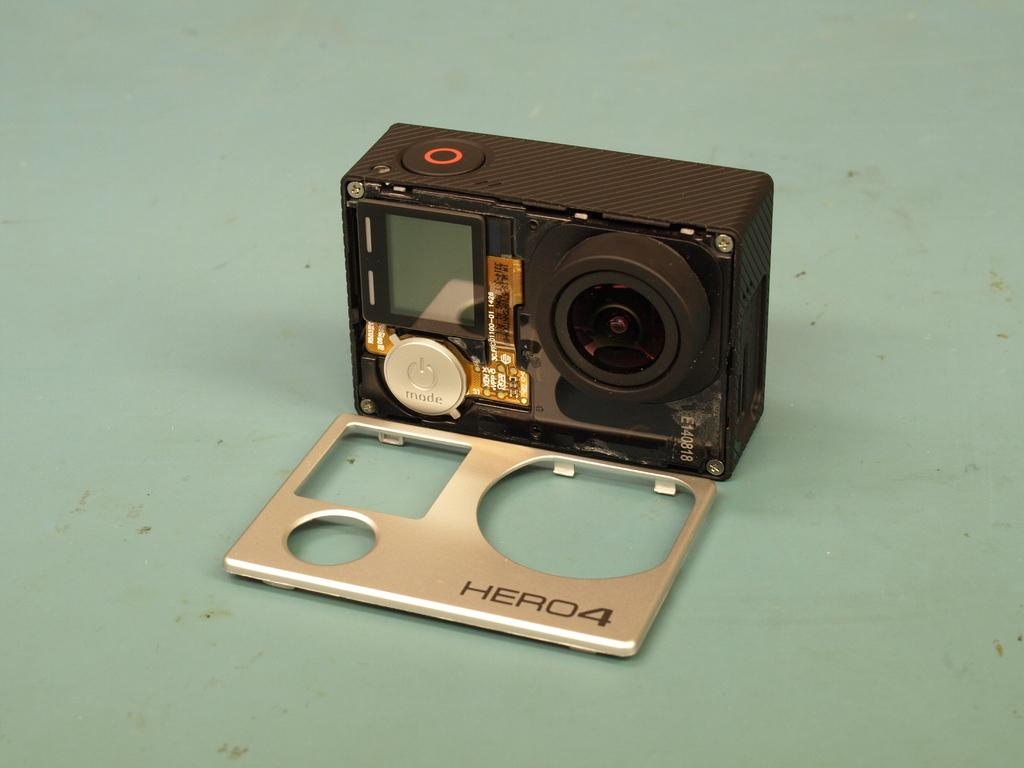What is the main subject in the center of the image? There is a camera in the center of the image. What is located at the bottom of the image? There is a table at the bottom of the image. What type of oven is visible in the image? There is no oven present in the image; it only features a camera and a table. 